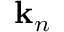Convert formula to latex. <formula><loc_0><loc_0><loc_500><loc_500>k _ { n }</formula> 